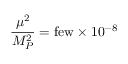<formula> <loc_0><loc_0><loc_500><loc_500>{ \frac { \mu ^ { 2 } } { M _ { P } ^ { 2 } } = f e w \times { 1 0 ^ { - 8 } } }</formula> 